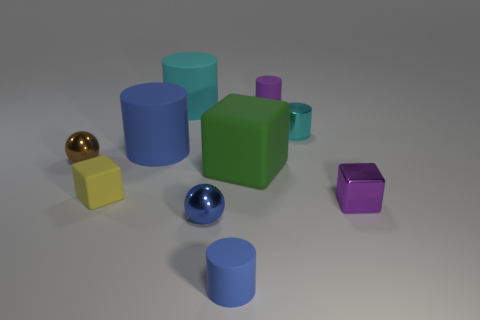Subtract all green cubes. How many cyan cylinders are left? 2 Subtract all small blocks. How many blocks are left? 1 Subtract all purple cylinders. How many cylinders are left? 4 Subtract 3 cylinders. How many cylinders are left? 2 Subtract all green cylinders. Subtract all brown blocks. How many cylinders are left? 5 Add 1 green matte things. How many green matte things exist? 2 Subtract 1 brown spheres. How many objects are left? 9 Subtract all spheres. How many objects are left? 8 Subtract all small blue metallic cylinders. Subtract all brown metallic objects. How many objects are left? 9 Add 5 large green cubes. How many large green cubes are left? 6 